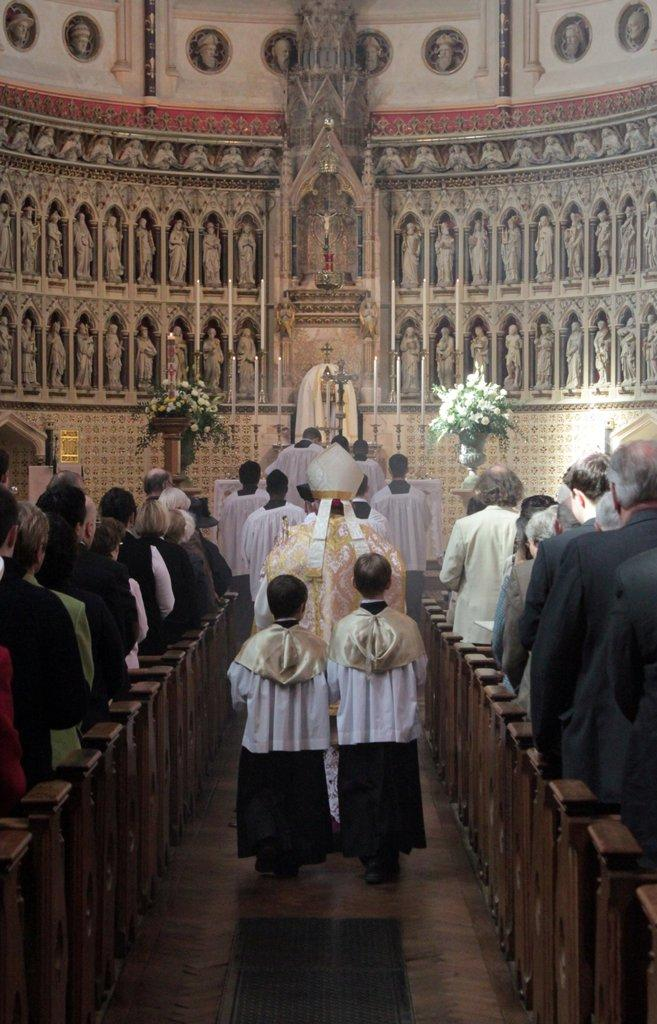What type of furniture is present in the image? There are chairs in the image. Who or what can be seen in the image? There are people and statues in the image. What decorative items are visible in the image? There are bouquets in the image. What type of development can be seen taking place in the image? There is no development or construction activity visible in the image. Can you describe the ray of light in the image? There is no ray of light present in the image. 